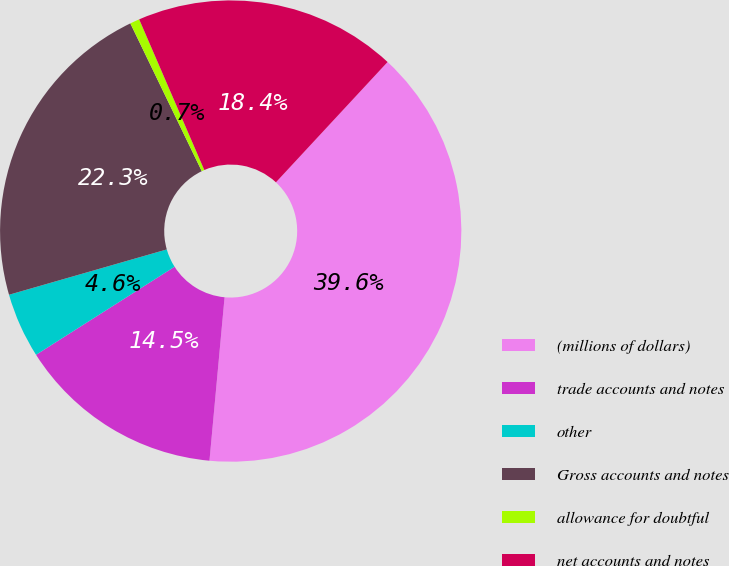Convert chart to OTSL. <chart><loc_0><loc_0><loc_500><loc_500><pie_chart><fcel>(millions of dollars)<fcel>trade accounts and notes<fcel>other<fcel>Gross accounts and notes<fcel>allowance for doubtful<fcel>net accounts and notes<nl><fcel>39.56%<fcel>14.52%<fcel>4.56%<fcel>22.29%<fcel>0.67%<fcel>18.4%<nl></chart> 